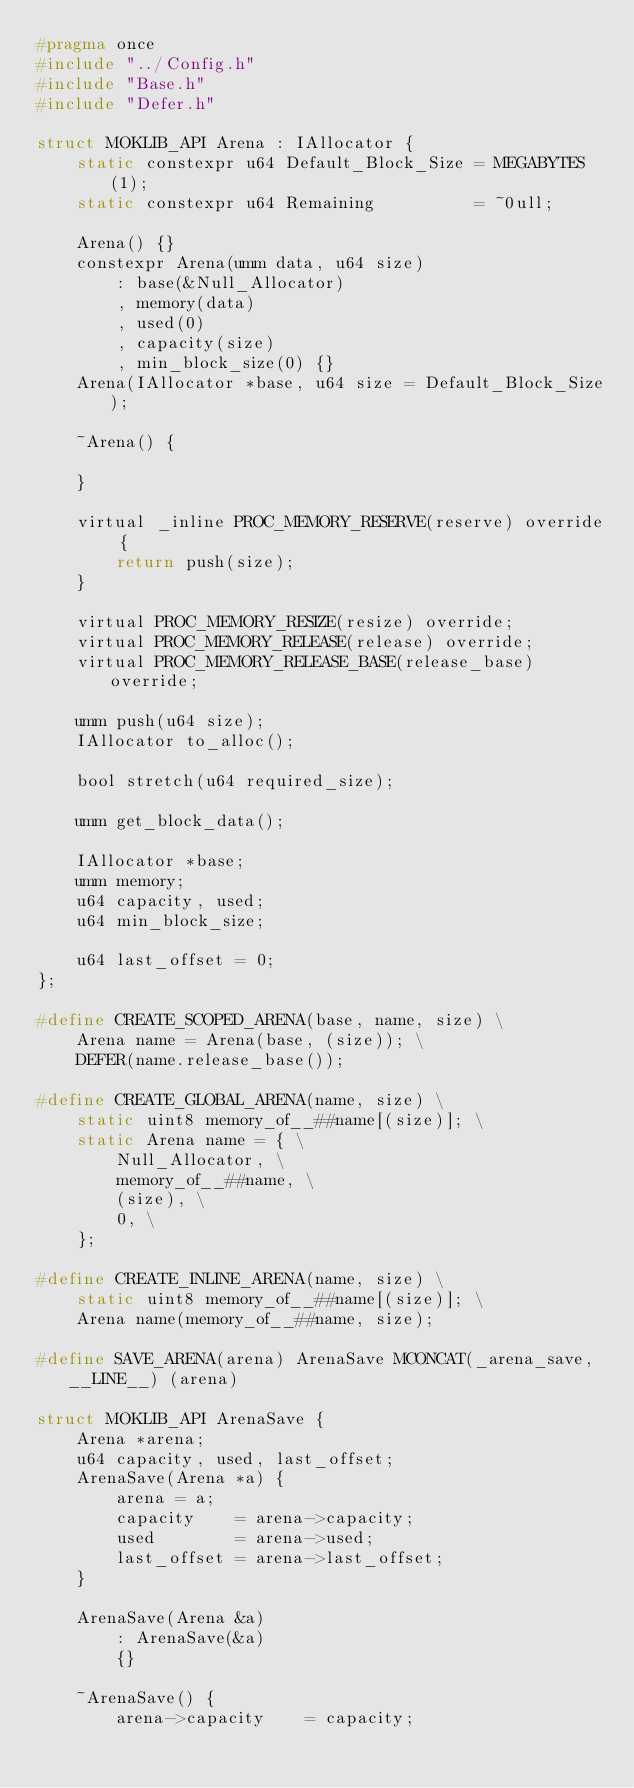Convert code to text. <code><loc_0><loc_0><loc_500><loc_500><_C_>#pragma once
#include "../Config.h"
#include "Base.h"
#include "Defer.h"

struct MOKLIB_API Arena : IAllocator {
	static constexpr u64 Default_Block_Size = MEGABYTES(1);
	static constexpr u64 Remaining 			= ~0ull;

	Arena() {}
	constexpr Arena(umm data, u64 size)
		: base(&Null_Allocator)
		, memory(data)
		, used(0)
		, capacity(size)
		, min_block_size(0) {}
	Arena(IAllocator *base, u64 size = Default_Block_Size);

	~Arena() {

	}

	virtual _inline PROC_MEMORY_RESERVE(reserve) override {
	    return push(size);
	}

	virtual PROC_MEMORY_RESIZE(resize) override;
	virtual PROC_MEMORY_RELEASE(release) override;
	virtual PROC_MEMORY_RELEASE_BASE(release_base) override;

	umm push(u64 size);
	IAllocator to_alloc();

	bool stretch(u64 required_size);

	umm get_block_data();

	IAllocator *base;
	umm memory;
	u64 capacity, used;
	u64 min_block_size;

	u64 last_offset = 0;
};

#define CREATE_SCOPED_ARENA(base, name, size) \
	Arena name = Arena(base, (size)); \
	DEFER(name.release_base());

#define CREATE_GLOBAL_ARENA(name, size) \
	static uint8 memory_of__##name[(size)]; \
	static Arena name = { \
		Null_Allocator, \
		memory_of__##name, \
		(size), \
		0, \
	};

#define CREATE_INLINE_ARENA(name, size) \
	static uint8 memory_of__##name[(size)]; \
	Arena name(memory_of__##name, size);

#define SAVE_ARENA(arena) ArenaSave MCONCAT(_arena_save, __LINE__) (arena)

struct MOKLIB_API ArenaSave {
	Arena *arena;
	u64 capacity, used, last_offset;
	ArenaSave(Arena *a) {
		arena = a;
		capacity    = arena->capacity;
		used        = arena->used;
		last_offset = arena->last_offset;
	}

	ArenaSave(Arena &a)
		: ArenaSave(&a)
		{}

	~ArenaSave() {
		arena->capacity    = capacity;</code> 